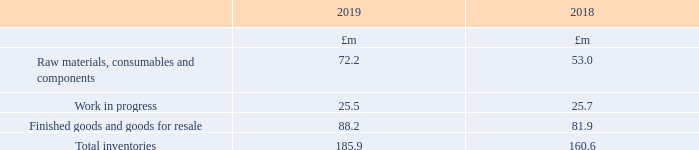17 Inventories
The write-down of inventories recognised as an expense during the year in respect of continuing operations was £0.7m (2018: £3.5m). This comprises a cost of £5.1m (2018: £4.8m) to write-down inventory to net realisable value reduced by £4.4m (2018: £1.3m) for reversal of previous write-down reassessed as a result of customer demand.
The value of inventories expected to be recovered after more than 12 months is £13.4m (2018: £11.2m).
There is no material difference between the Statement of Financial Position value of inventories and their replacement cost. None of the inventory has been pledged as security.
What did the write-down of inventories recognised as an expense during the year in respect of continuing operations comprise of? A cost of £5.1m (2018: £4.8m) to write-down inventory to net realisable value reduced by £4.4m (2018: £1.3m) for reversal of previous write-down reassessed as a result of customer demand. What is the value of inventories expected to be recovered after more than 12 months in 2019? £13.4m. What are the components which make up the total inventories? Raw materials, consumables and components, work in progress, finished goods and goods for resale. In which year was the Work in progress value larger? 25.5<25.7
Answer: 2018. What was the change in total inventories from 2018 to 2019?
Answer scale should be: million. 185.9-160.6
Answer: 25.3. What was the percentage change in total inventories from 2018 to 2019?
Answer scale should be: percent. (185.9-160.6)/160.6
Answer: 15.75. 